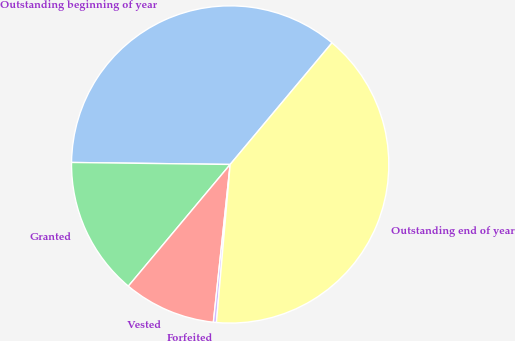<chart> <loc_0><loc_0><loc_500><loc_500><pie_chart><fcel>Outstanding beginning of year<fcel>Granted<fcel>Vested<fcel>Forfeited<fcel>Outstanding end of year<nl><fcel>35.89%<fcel>14.11%<fcel>9.4%<fcel>0.31%<fcel>40.28%<nl></chart> 